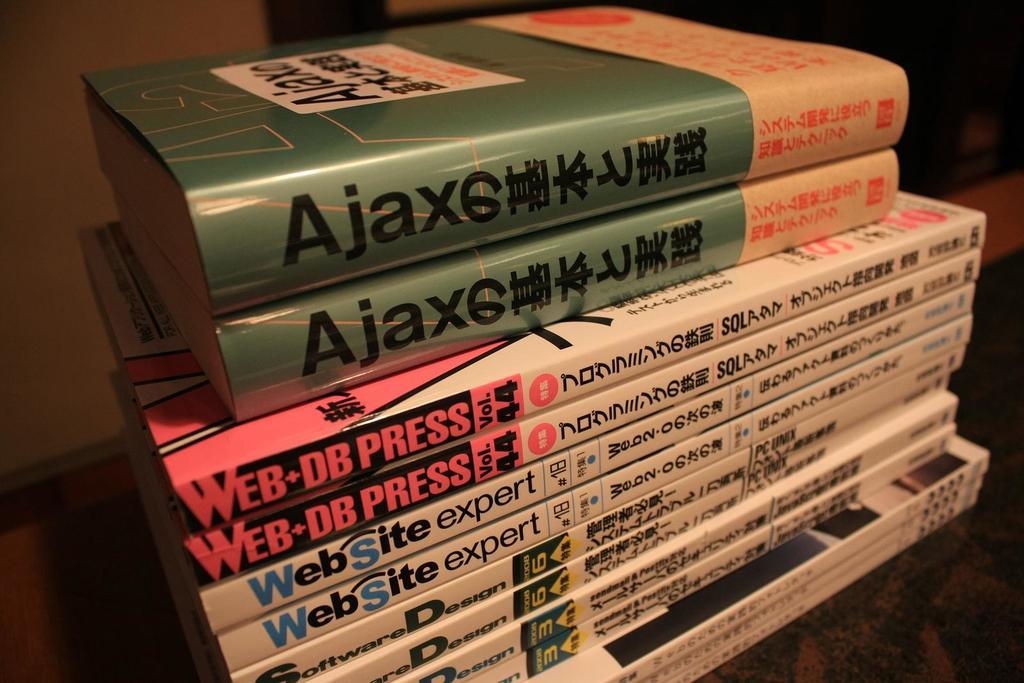What expert level books are shown here?
Provide a short and direct response. Website. What kind of expert book is shown?
Provide a succinct answer. Website. 